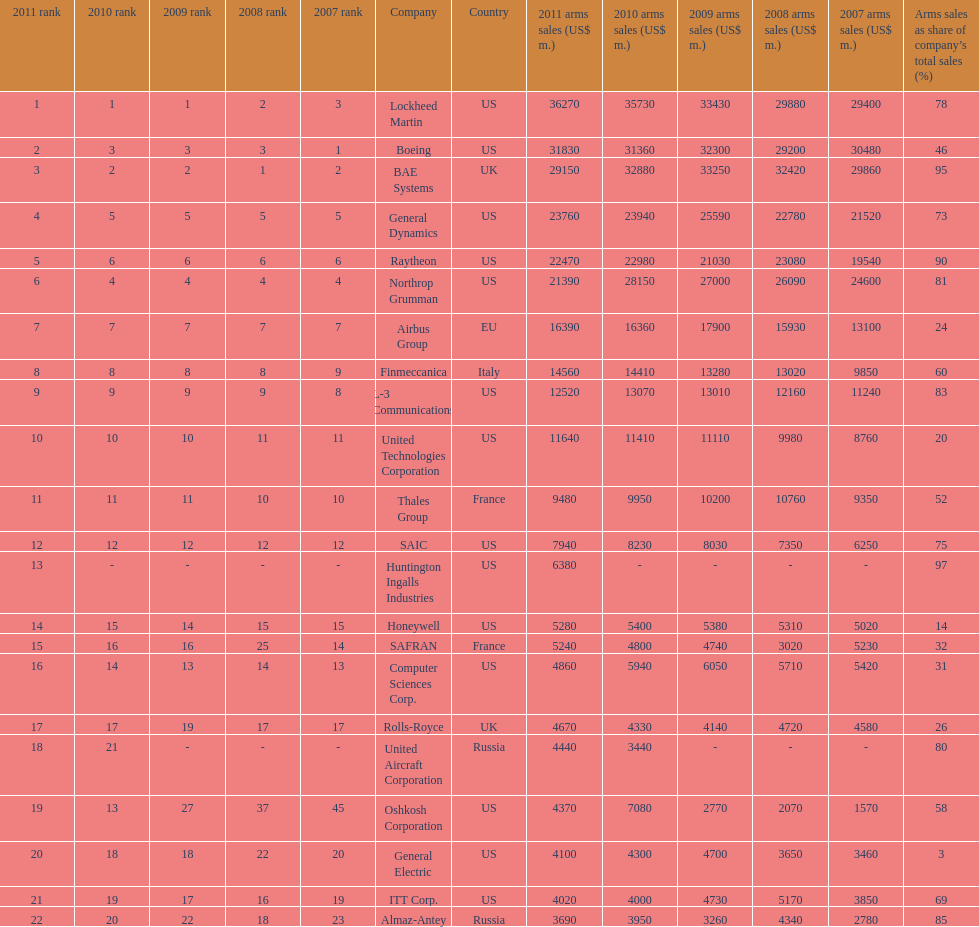Which is the only company to have under 10% arms sales as share of company's total sales? General Electric. 